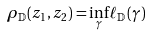<formula> <loc_0><loc_0><loc_500><loc_500>\rho _ { \mathbb { D } } ( z _ { 1 } , z _ { 2 } ) = \inf _ { \gamma } \ell _ { \mathbb { D } } ( \gamma )</formula> 